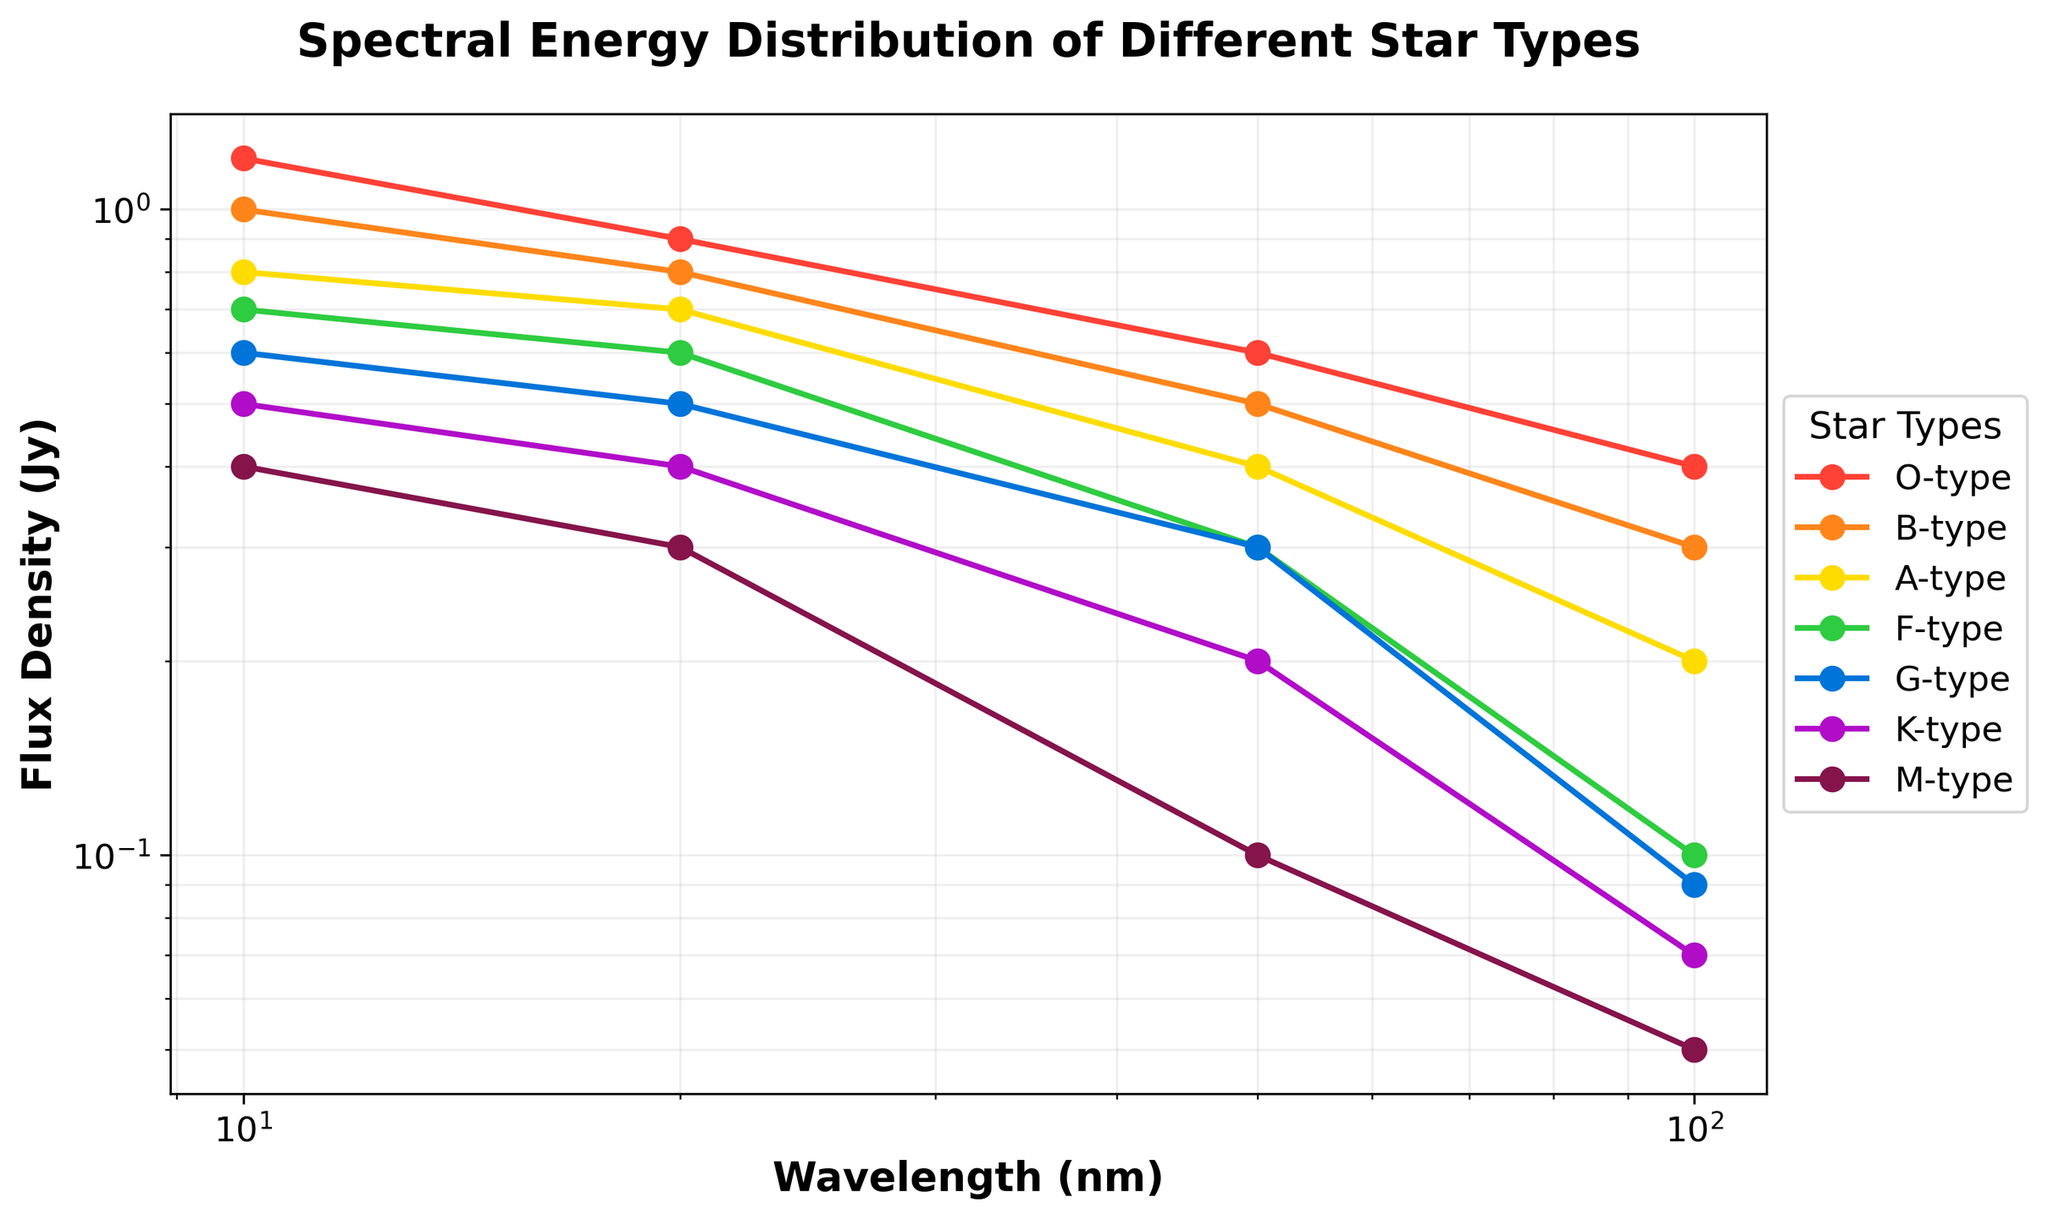What is the title of the plot? The title of the plot is given at the top of the figure. It helps in understanding the main topic or focus of the plot.
Answer: Spectral Energy Distribution of Different Star Types What is the x-axis label? The label of the x-axis is displayed along the horizontal axis to indicate what variable is being measured.
Answer: Wavelength (nm) How many star types are represented in the plot? Count the unique labels in the legend which represents the different star types.
Answer: 7 Which star type has the highest flux density at a wavelength of 10 nm? Locate the data points at 10 nm on the x-axis and identify the star type associated with the highest value on the y-axis.
Answer: O-type At what wavelength does the M-type star have the lowest flux density? Locate the M-type star data points and find the lowest value on the y-axis, then check the corresponding x-axis value.
Answer: 100 nm How does the flux density of G-type stars change from 10 nm to 100 nm? Observe the G-type star data points and note the trend in their values from 10 nm through 100 nm on the x-axis.
Answer: Decreases Which star type has the most significant drop in flux density between 20 nm and 100 nm? Compare the flux density values at 20 nm and 100 nm for each star type, then identify which star type shows the largest decrease.
Answer: O-type What is the flux density of F-type stars at 50 nm? Locate the data point for F-type stars on the plot at 50 nm on the x-axis and read the corresponding value on the y-axis.
Answer: 0.3 Jy Between A-type and B-type stars, which one has a higher average flux density? Calculate the average flux density for both A-type and B-type stars using their respective data points, then compare the averages.
Answer: B-type How many data points are plotted for each star type? Count the number of markers plotted for any one star type, as they all seem to have the same number of data points.
Answer: 4 